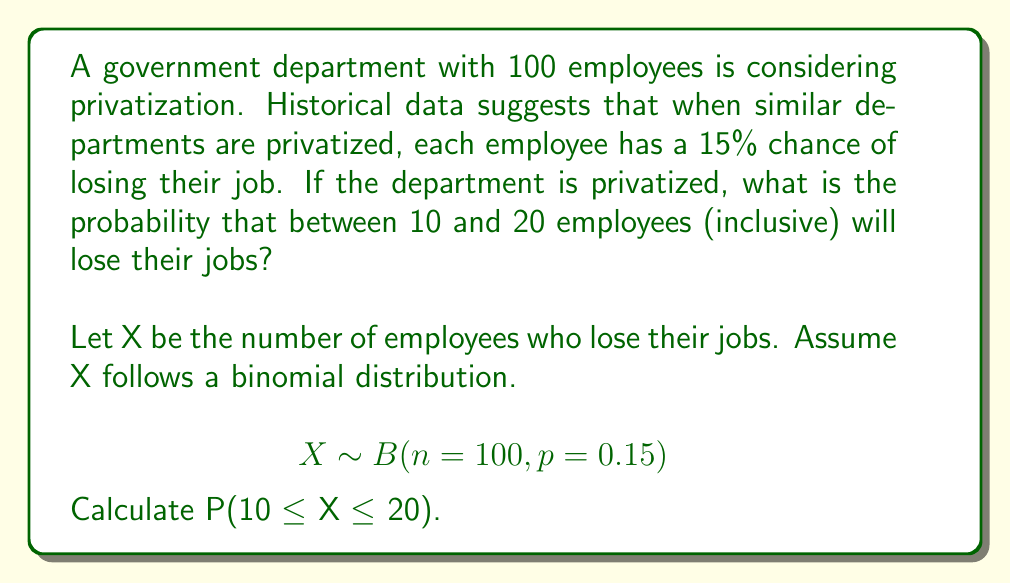Show me your answer to this math problem. To solve this problem, we'll use the binomial distribution and the cumulative distribution function (CDF).

1) The binomial distribution parameters are:
   n = 100 (number of employees)
   p = 0.15 (probability of job loss for each employee)

2) We need to find P(10 ≤ X ≤ 20), which is equivalent to:
   P(X ≤ 20) - P(X ≤ 9)

3) For a binomial distribution, we can use the cumulative distribution function:
   $$P(X \leq k) = \sum_{i=0}^k \binom{n}{i} p^i (1-p)^{n-i}$$

4) Using a statistical calculator or software (as manual calculation would be tedious):
   P(X ≤ 20) ≈ 0.9643
   P(X ≤ 9) ≈ 0.0432

5) Therefore:
   P(10 ≤ X ≤ 20) = P(X ≤ 20) - P(X ≤ 9)
                   ≈ 0.9643 - 0.0432
                   ≈ 0.9211

6) Convert to percentage:
   0.9211 × 100% ≈ 92.11%
Answer: 92.11% 